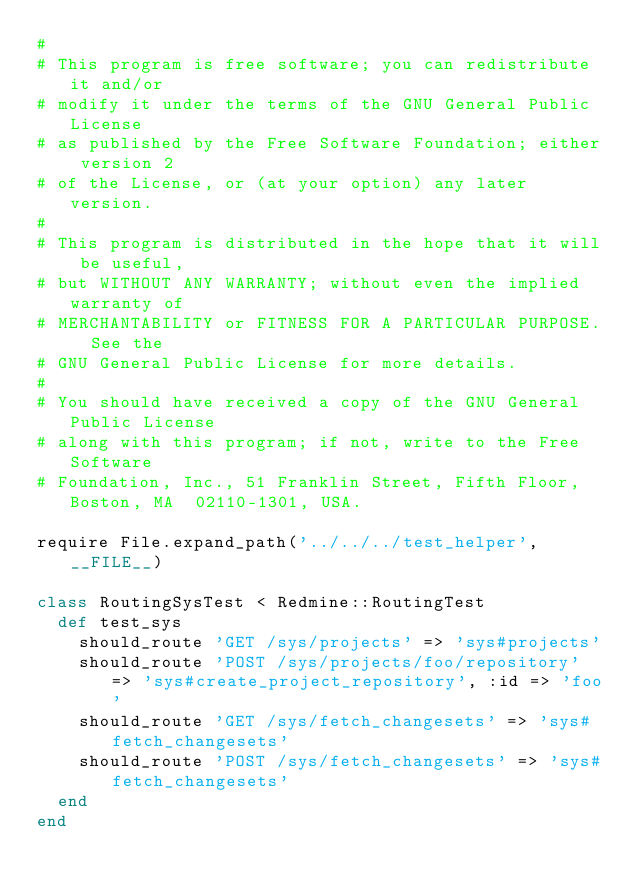Convert code to text. <code><loc_0><loc_0><loc_500><loc_500><_Ruby_>#
# This program is free software; you can redistribute it and/or
# modify it under the terms of the GNU General Public License
# as published by the Free Software Foundation; either version 2
# of the License, or (at your option) any later version.
#
# This program is distributed in the hope that it will be useful,
# but WITHOUT ANY WARRANTY; without even the implied warranty of
# MERCHANTABILITY or FITNESS FOR A PARTICULAR PURPOSE.  See the
# GNU General Public License for more details.
#
# You should have received a copy of the GNU General Public License
# along with this program; if not, write to the Free Software
# Foundation, Inc., 51 Franklin Street, Fifth Floor, Boston, MA  02110-1301, USA.

require File.expand_path('../../../test_helper', __FILE__)

class RoutingSysTest < Redmine::RoutingTest
  def test_sys
    should_route 'GET /sys/projects' => 'sys#projects'
    should_route 'POST /sys/projects/foo/repository' => 'sys#create_project_repository', :id => 'foo'
    should_route 'GET /sys/fetch_changesets' => 'sys#fetch_changesets'
    should_route 'POST /sys/fetch_changesets' => 'sys#fetch_changesets'
  end
end
</code> 